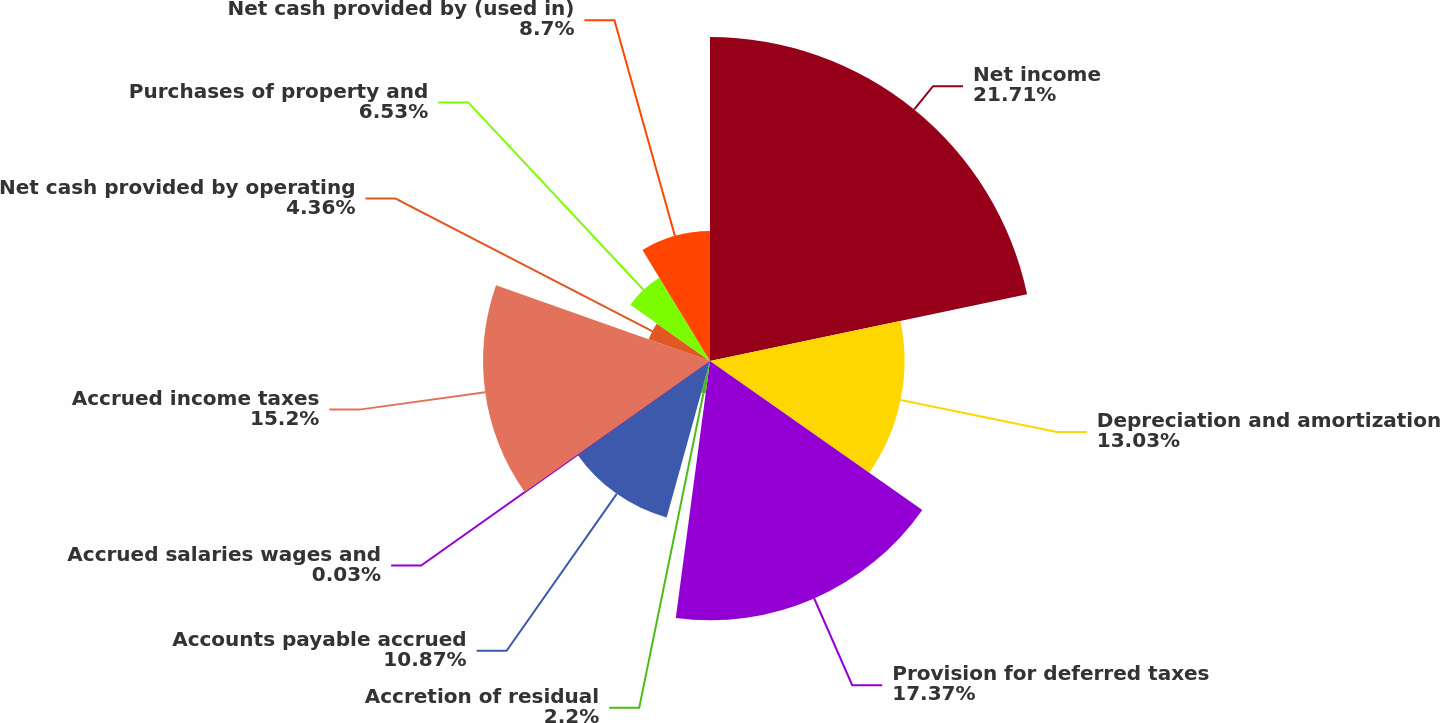<chart> <loc_0><loc_0><loc_500><loc_500><pie_chart><fcel>Net income<fcel>Depreciation and amortization<fcel>Provision for deferred taxes<fcel>Accretion of residual<fcel>Accounts payable accrued<fcel>Accrued salaries wages and<fcel>Accrued income taxes<fcel>Net cash provided by operating<fcel>Purchases of property and<fcel>Net cash provided by (used in)<nl><fcel>21.7%<fcel>13.03%<fcel>17.37%<fcel>2.2%<fcel>10.87%<fcel>0.03%<fcel>15.2%<fcel>4.36%<fcel>6.53%<fcel>8.7%<nl></chart> 